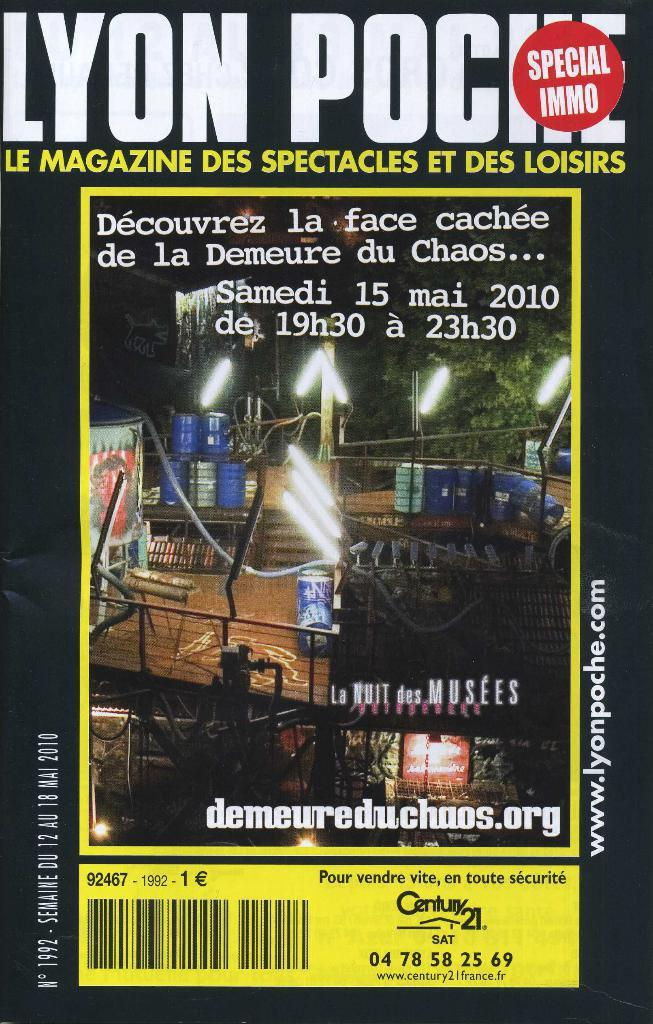<image>
Provide a brief description of the given image. Poster that says "Lyon Pociie" and is a Special immo. 